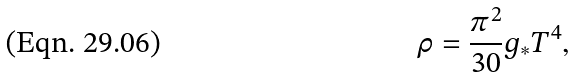Convert formula to latex. <formula><loc_0><loc_0><loc_500><loc_500>\rho = \frac { \pi ^ { 2 } } { 3 0 } g _ { * } T ^ { 4 } ,</formula> 